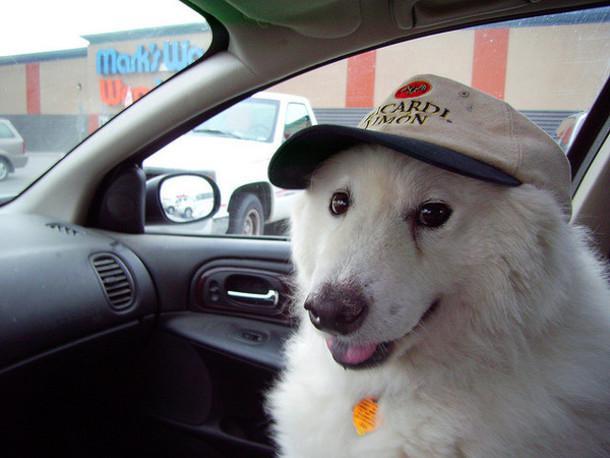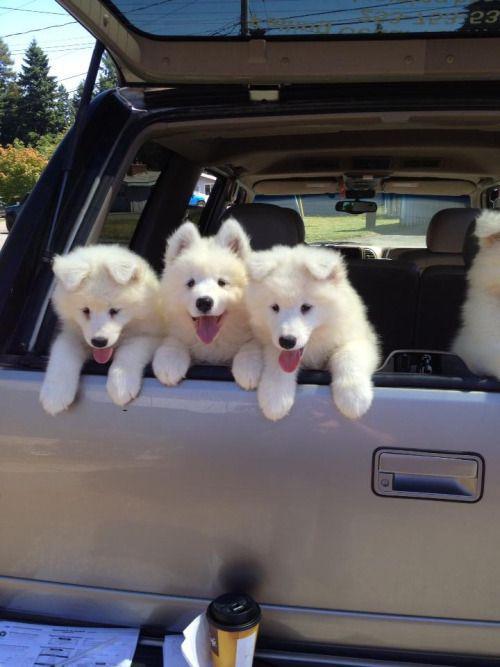The first image is the image on the left, the second image is the image on the right. Given the left and right images, does the statement "There are no more than three dogs and one of them has it's mouth open." hold true? Answer yes or no. No. 